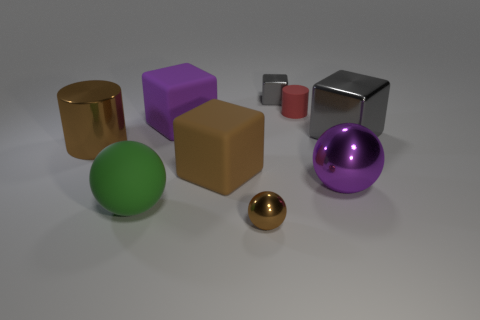There is a gray object that is the same size as the red matte cylinder; what is its shape? The gray object that matches the red cylinder in size has a cubic form, with six equal square faces and edges that meet at right angles. 